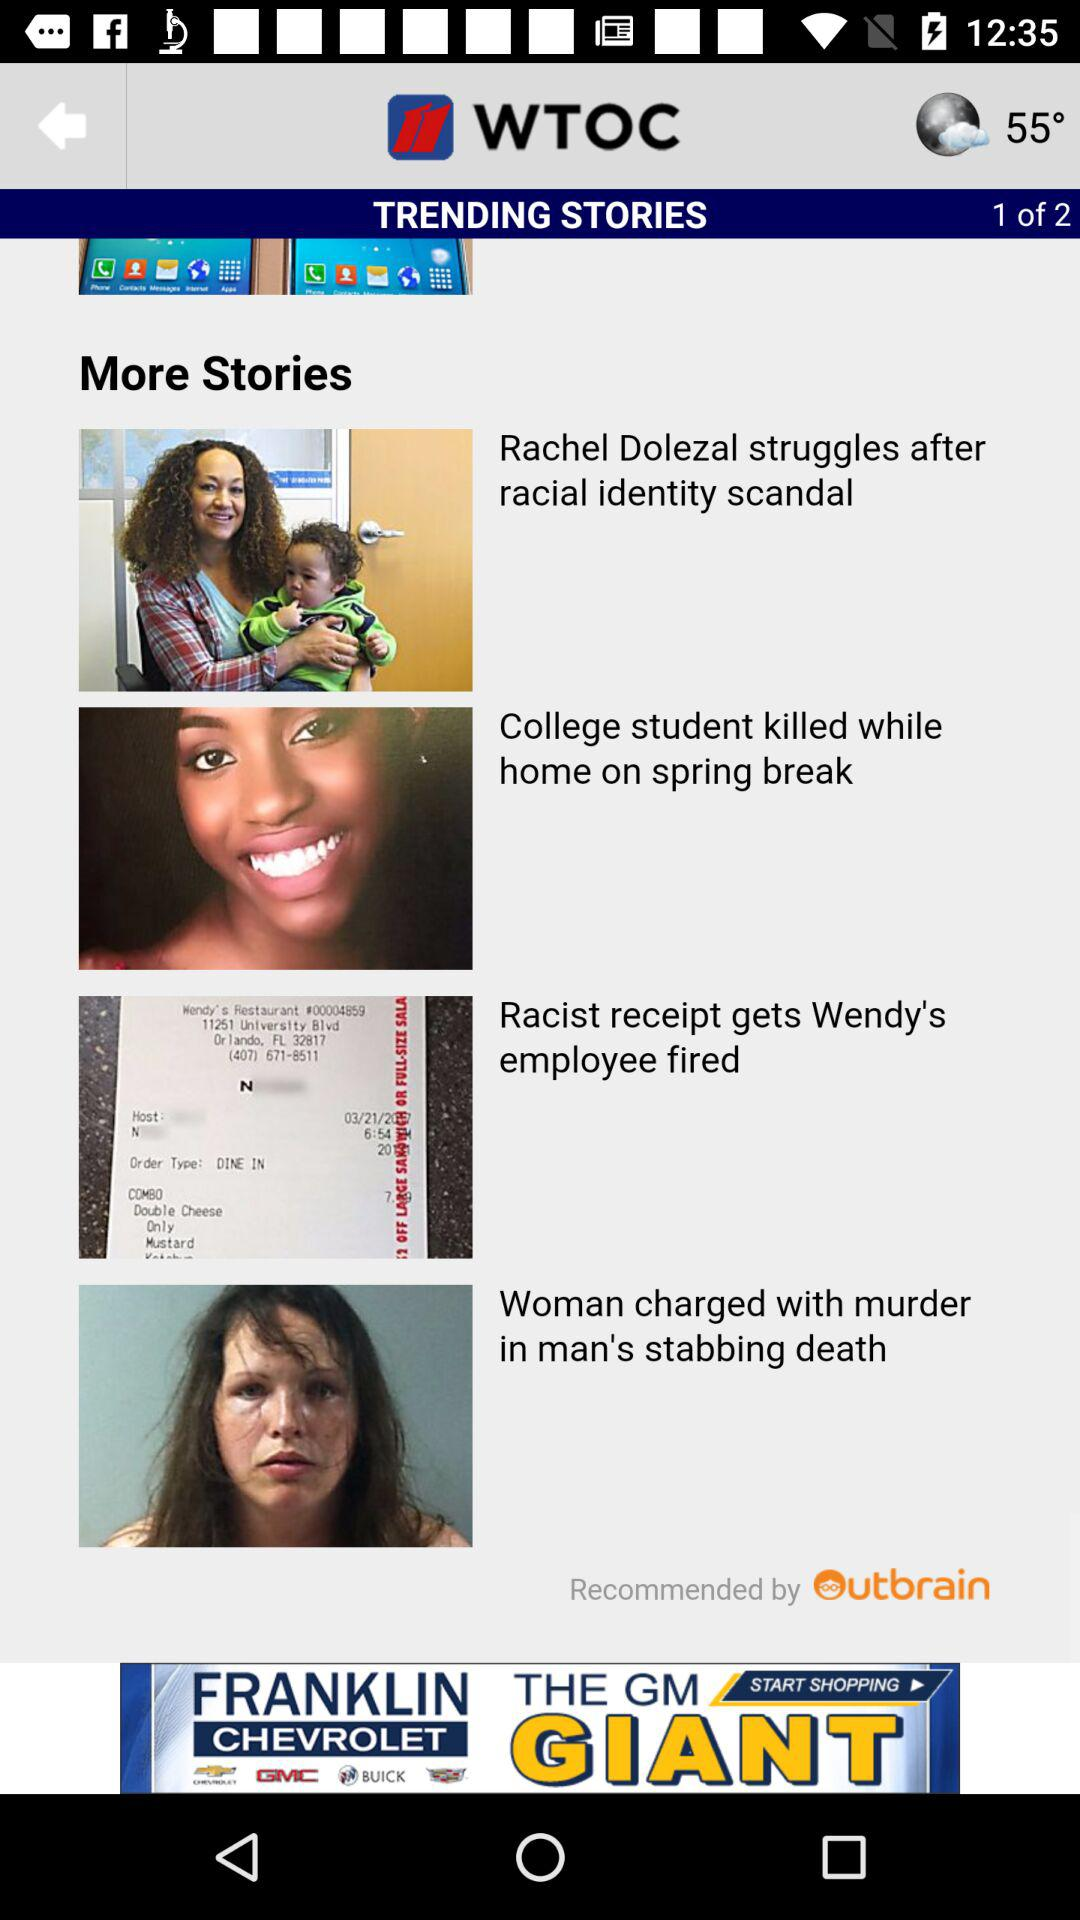What is the application name? The application name is "11 WTOC". 